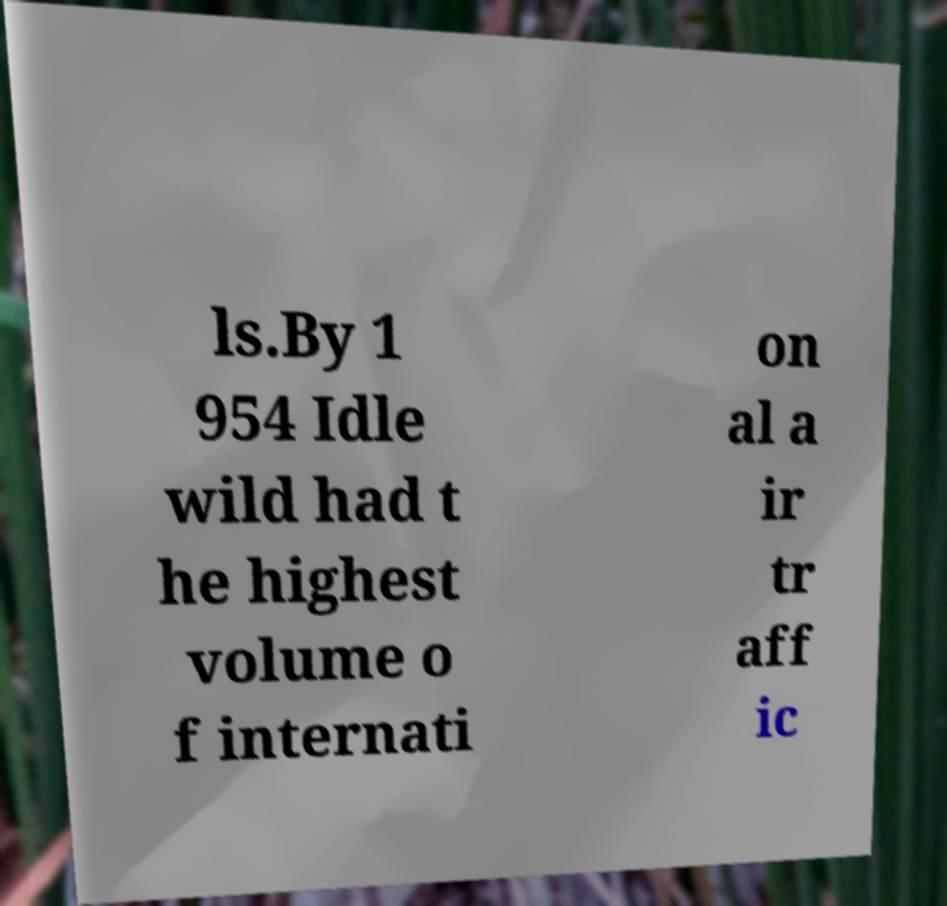Please read and relay the text visible in this image. What does it say? ls.By 1 954 Idle wild had t he highest volume o f internati on al a ir tr aff ic 